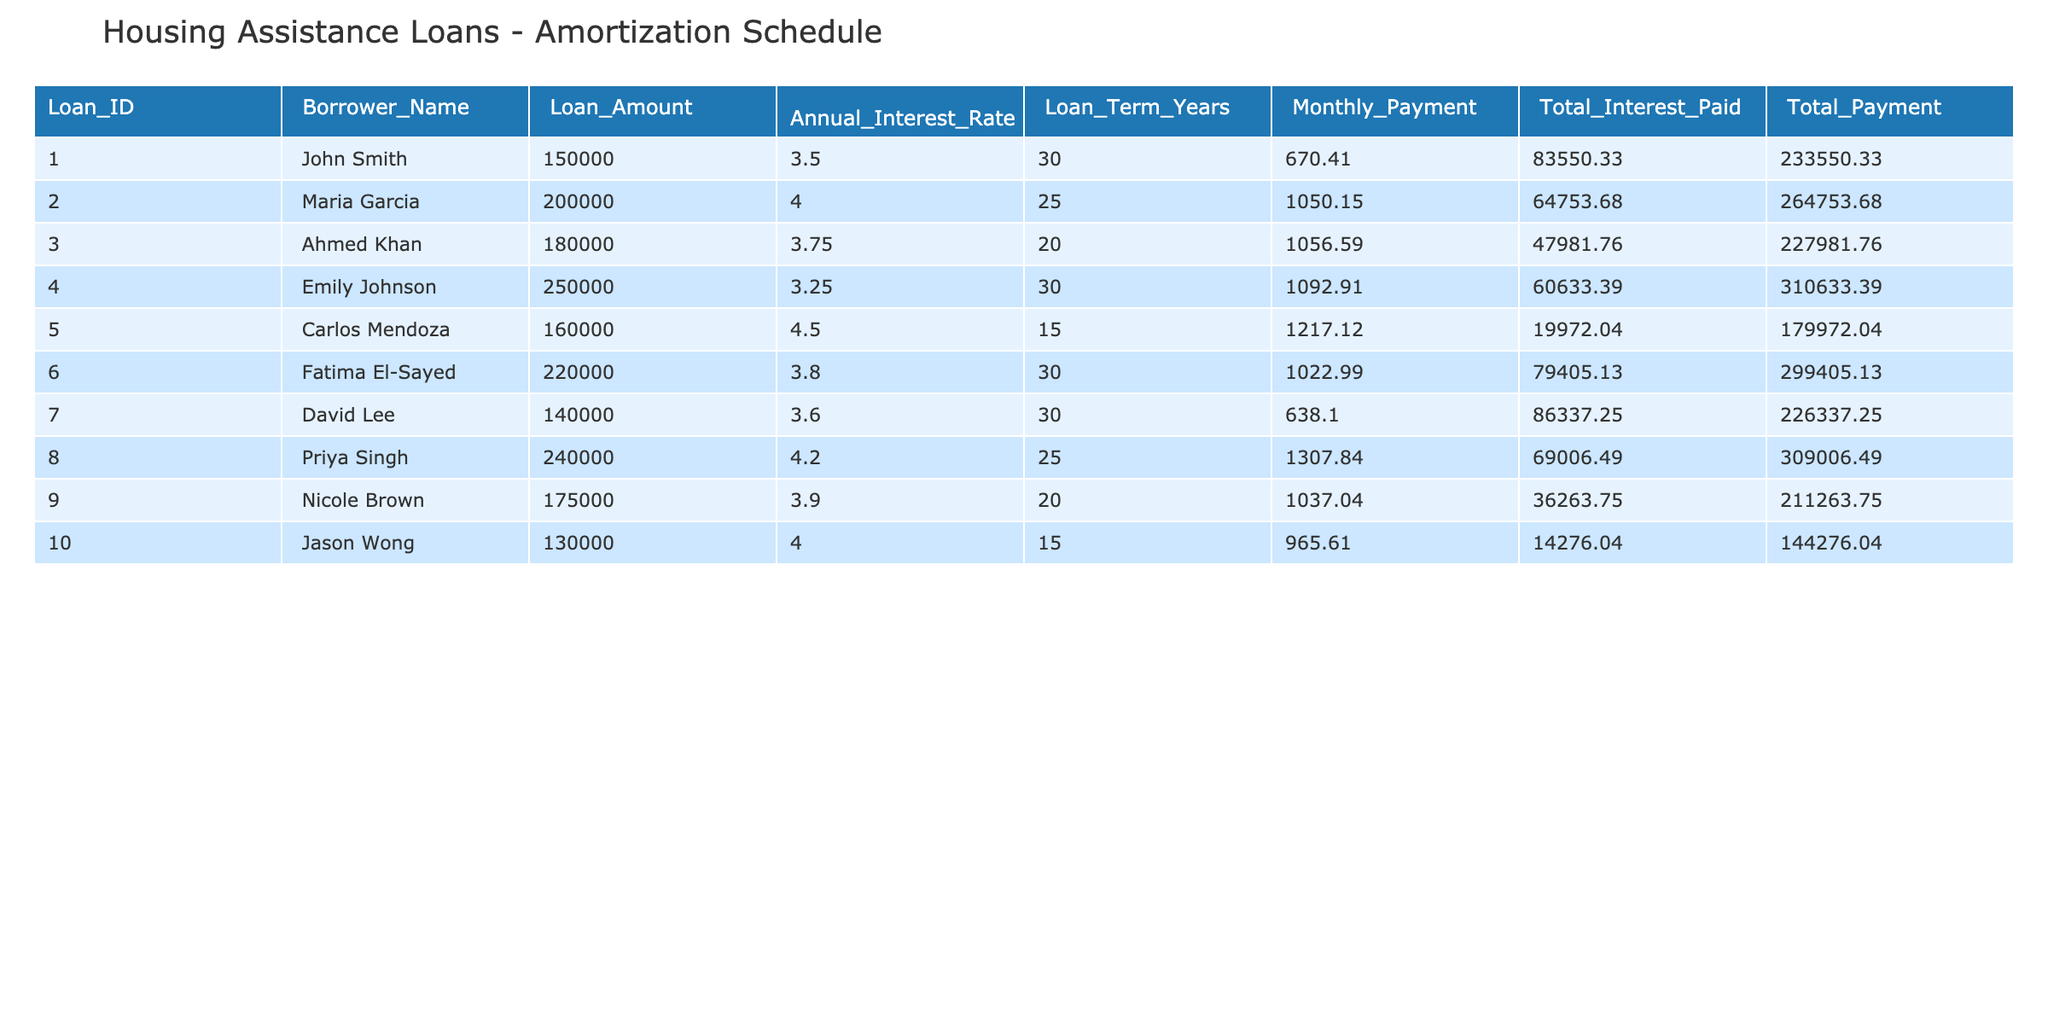What is the loan amount for Fatima El-Sayed? In the table, I can find Fatima El-Sayed's row. The loan amount for her is listed in the "Loan_Amount" column. It is 220000.
Answer: 220000 What is the total payment for Carlos Mendoza? Looking at the row for Carlos Mendoza, the total payment can be found in the "Total_Payment" column. His total payment is 179972.04.
Answer: 179972.04 Which borrower has the highest total interest paid? I need to compare the values in the "Total_Interest_Paid" column. Scanning through the rows, I see that John Smith has a total interest paid of 83550.33, which is the highest among all borrowers.
Answer: John Smith What is the average monthly payment for all borrowers? To calculate the average, I first sum up all the monthly payments: 670.41 + 1050.15 + 1056.59 + 1092.91 + 1217.12 + 1022.99 + 638.10 + 1307.84 + 1037.04 + 965.61 = 10698.85. Then, I divide this by the number of borrowers (10), which results in an average of 1069.885.
Answer: 1069.89 Is Emily Johnson's loan amount greater than the average loan amount of all borrowers? First, I need to find the average loan amount. The total loan amount is 150000 + 200000 + 180000 + 250000 + 160000 + 220000 + 140000 + 240000 + 175000 + 130000 = 1850000. Dividing this by the number of borrowers (10) gives an average of 185000. Since Emily's loan amount is 250000, which is greater than 185000, the answer is yes.
Answer: Yes What is the total interest paid by Jason Wong and Nicole Brown combined? I will find the total interest paid by both borrowers. For Jason Wong, it is 14276.04 and for Nicole Brown, it is 36263.75. Adding these together gives 14276.04 + 36263.75 = 50539.79.
Answer: 50539.79 Which borrowers have a total payment less than 250000? I will check the "Total_Payment" column for each borrower. The values that are less than 250000 are for John Smith (233550.33), Carlos Mendoza (179972.04), and Jason Wong (144276.04). So, the borrowers are John Smith, Carlos Mendoza, and Jason Wong.
Answer: John Smith, Carlos Mendoza, Jason Wong What is the difference in loan amounts between the highest and lowest loan amounts? I need to identify the highest and lowest loan amounts. The highest is 250000 (Emily Johnson) and the lowest is 130000 (Jason Wong). The difference is calculated as 250000 - 130000 = 120000.
Answer: 120000 